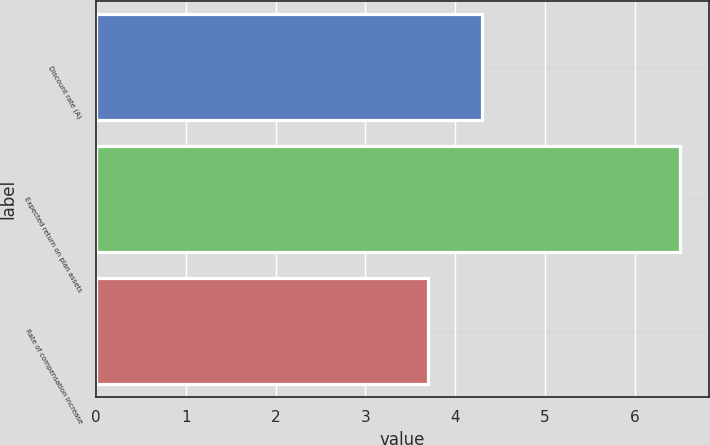Convert chart to OTSL. <chart><loc_0><loc_0><loc_500><loc_500><bar_chart><fcel>Discount rate (A)<fcel>Expected return on plan assets<fcel>Rate of compensation increase<nl><fcel>4.3<fcel>6.5<fcel>3.7<nl></chart> 